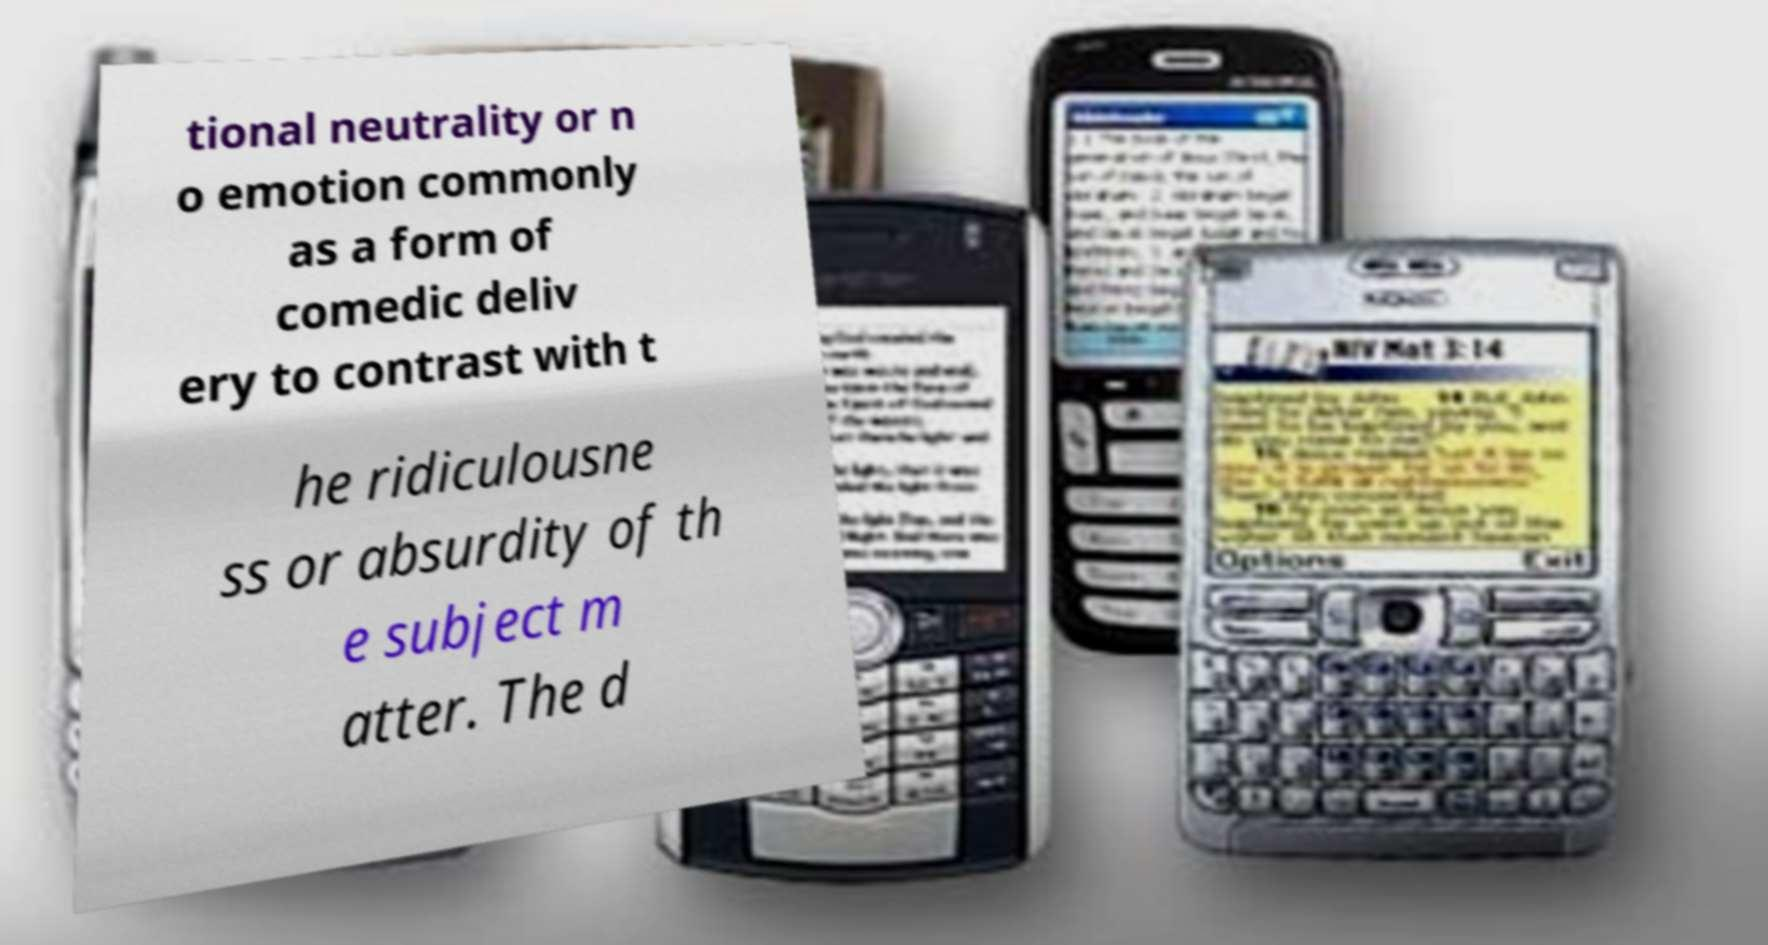What messages or text are displayed in this image? I need them in a readable, typed format. tional neutrality or n o emotion commonly as a form of comedic deliv ery to contrast with t he ridiculousne ss or absurdity of th e subject m atter. The d 